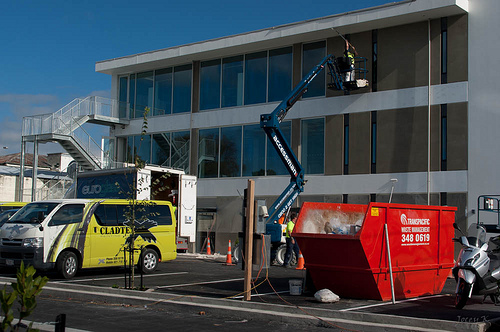<image>
Is there a tire in front of the cone? Yes. The tire is positioned in front of the cone, appearing closer to the camera viewpoint. Is there a man above the ground? Yes. The man is positioned above the ground in the vertical space, higher up in the scene. 